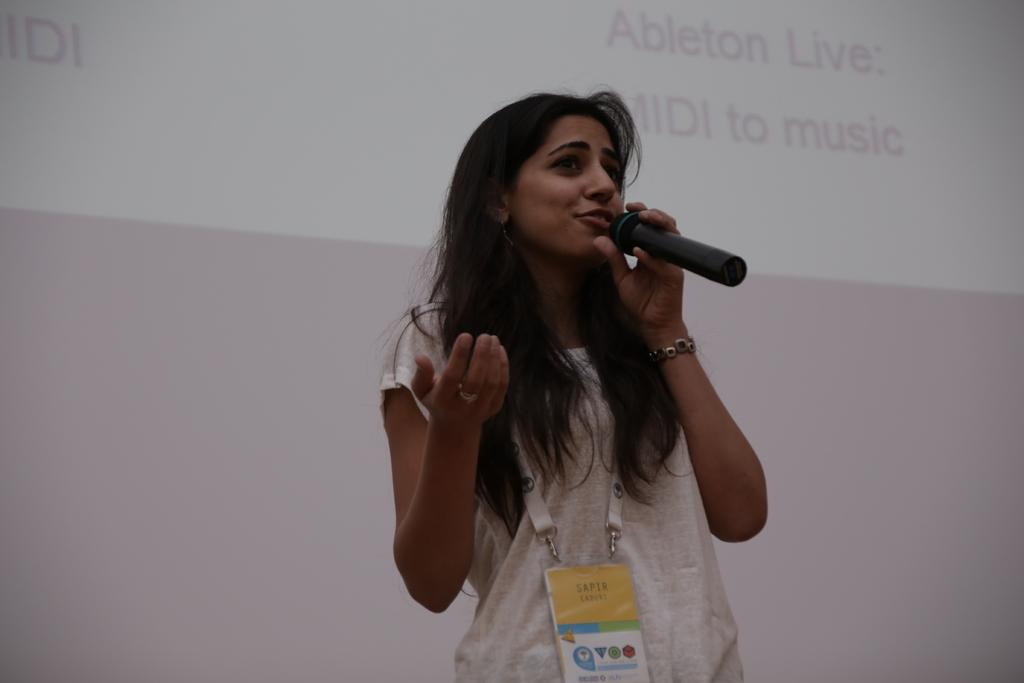Who is the main subject in the image? There is a woman in the image. What is the woman wearing? The woman is wearing a white shirt. Is there any additional detail about the woman's attire? Yes, the woman is wearing a tag. What is the woman doing in the image? The woman is talking into a microphone. How is the microphone being held? The microphone is held in her hand. What can be seen in the background of the image? There is a screen visible in the background of the image. What type of winter activity is the woman participating in the image? There is no indication of winter or any winter activity in the image. Can you tell me how many toes the woman has in the image? The image does not show the woman's toes, so it is not possible to determine the number of toes she has. 